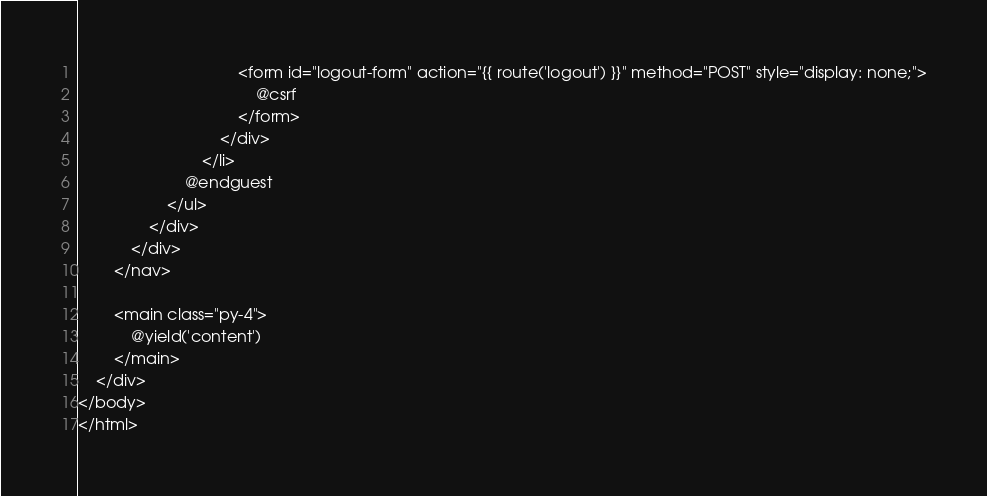Convert code to text. <code><loc_0><loc_0><loc_500><loc_500><_PHP_>
                                    <form id="logout-form" action="{{ route('logout') }}" method="POST" style="display: none;">
                                        @csrf
                                    </form>
                                </div>
                            </li>
                        @endguest
                    </ul>
                </div>
            </div>
        </nav>

        <main class="py-4">
            @yield('content')
        </main>
    </div>
</body>
</html>
</code> 